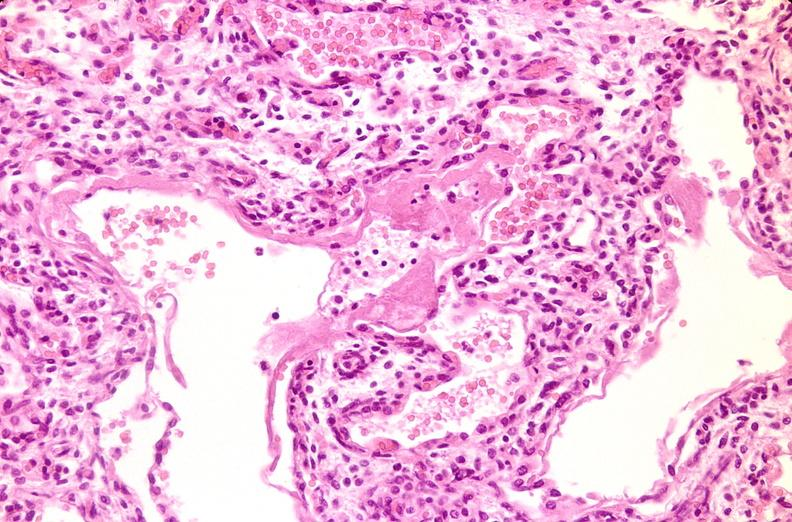does high excellent steroid show lungs, hyaline membrane disease?
Answer the question using a single word or phrase. No 